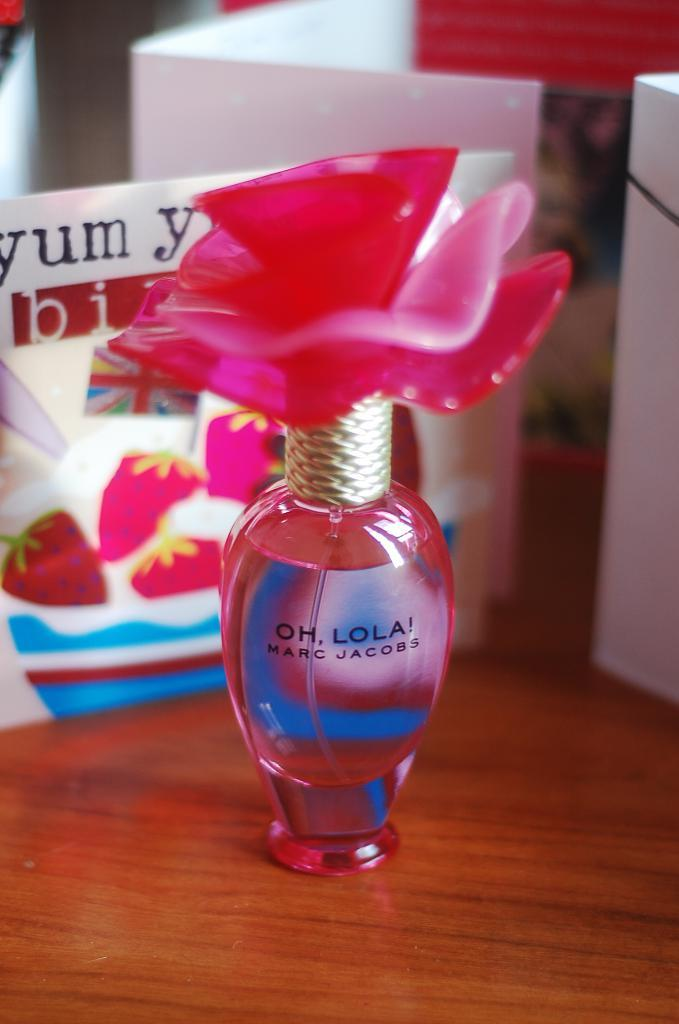Provide a one-sentence caption for the provided image. A bottle of Marc Jacobs perfume is pink in color. 